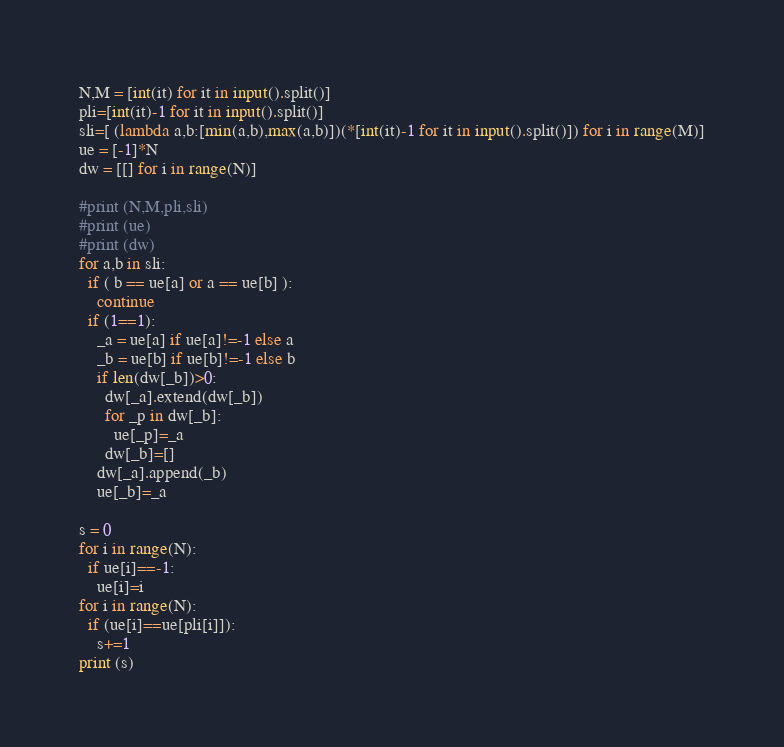Convert code to text. <code><loc_0><loc_0><loc_500><loc_500><_Python_>N,M = [int(it) for it in input().split()]
pli=[int(it)-1 for it in input().split()]
sli=[ (lambda a,b:[min(a,b),max(a,b)])(*[int(it)-1 for it in input().split()]) for i in range(M)]
ue = [-1]*N
dw = [[] for i in range(N)]

#print (N,M,pli,sli)
#print (ue)
#print (dw)
for a,b in sli:
  if ( b == ue[a] or a == ue[b] ):
    continue
  if (1==1):
    _a = ue[a] if ue[a]!=-1 else a 
    _b = ue[b] if ue[b]!=-1 else b
    if len(dw[_b])>0:
      dw[_a].extend(dw[_b])
      for _p in dw[_b]:
        ue[_p]=_a
      dw[_b]=[]
    dw[_a].append(_b)
    ue[_b]=_a

s = 0
for i in range(N):
  if ue[i]==-1:
    ue[i]=i 
for i in range(N):
  if (ue[i]==ue[pli[i]]):
    s+=1
print (s)</code> 